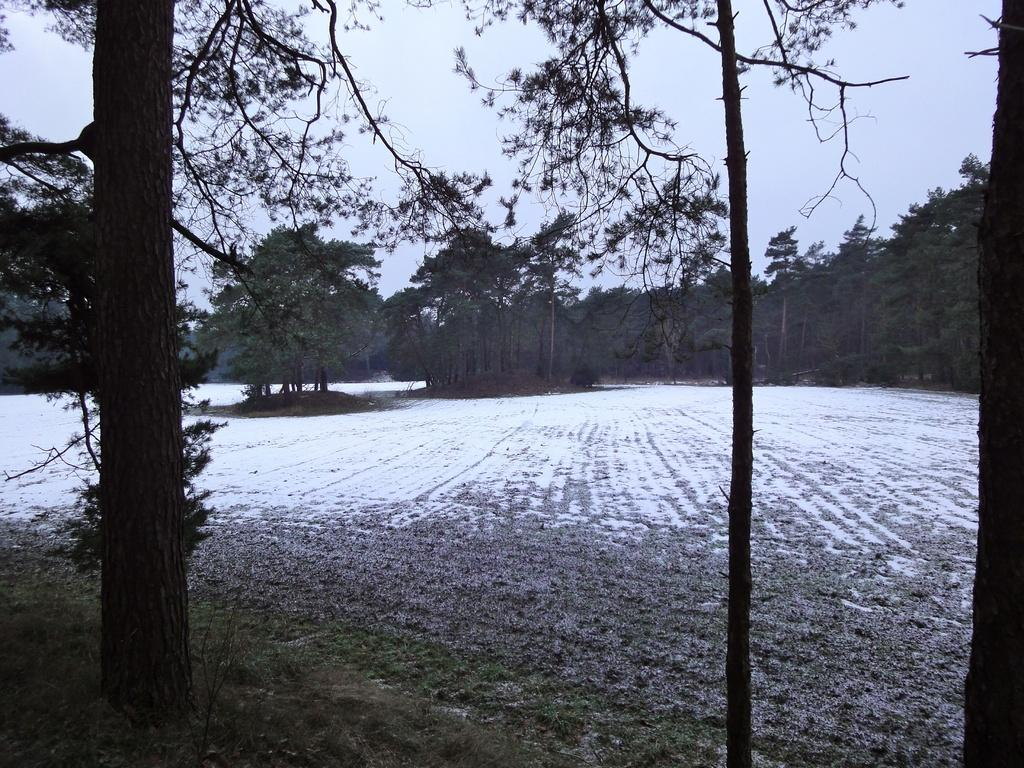Where was the image taken? The image was clicked outside. What can be seen at the bottom of the image? There is a ground at the bottom of the image? What is visible at the top of the image? The sky is visible at the top of the image. How many dimes can be seen floating on the waves in the image? There are no dimes or waves present in the image; it features a ground, trees, and the sky. 